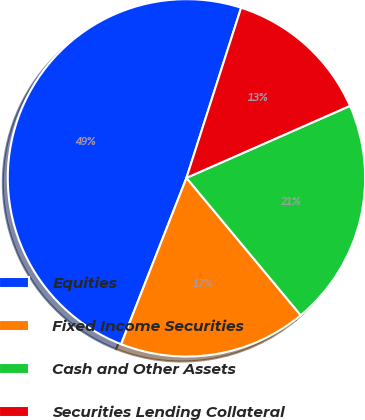<chart> <loc_0><loc_0><loc_500><loc_500><pie_chart><fcel>Equities<fcel>Fixed Income Securities<fcel>Cash and Other Assets<fcel>Securities Lending Collateral<nl><fcel>48.99%<fcel>17.0%<fcel>20.56%<fcel>13.45%<nl></chart> 